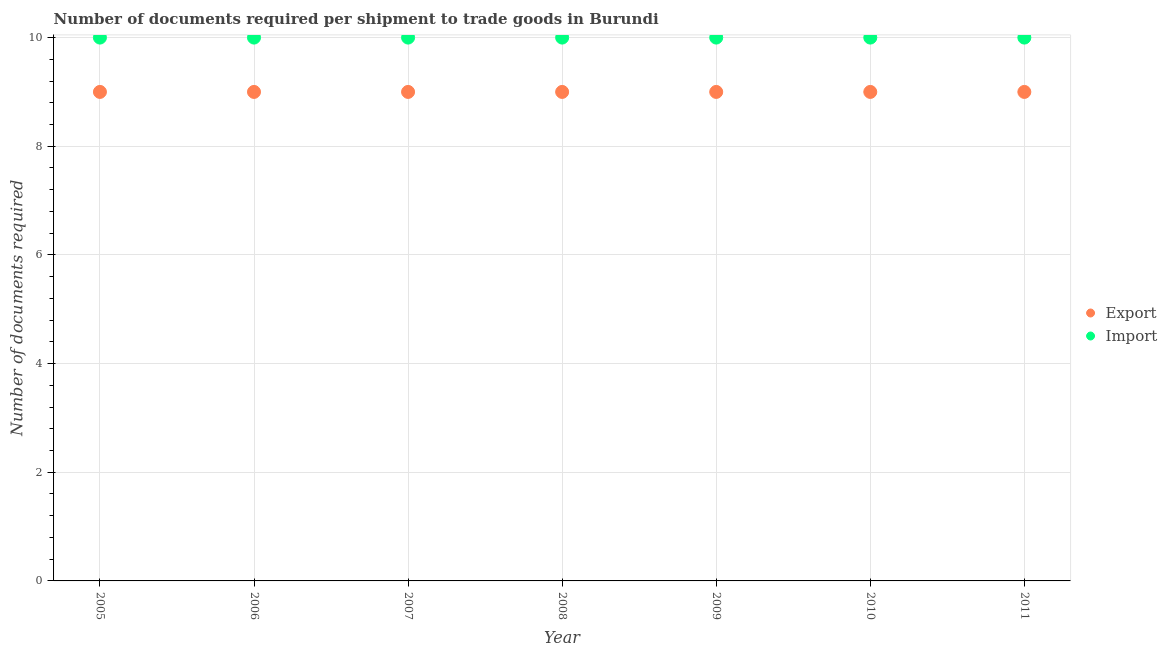How many different coloured dotlines are there?
Offer a terse response. 2. Is the number of dotlines equal to the number of legend labels?
Your response must be concise. Yes. What is the number of documents required to import goods in 2007?
Make the answer very short. 10. Across all years, what is the maximum number of documents required to export goods?
Provide a short and direct response. 9. Across all years, what is the minimum number of documents required to export goods?
Provide a succinct answer. 9. In which year was the number of documents required to export goods minimum?
Ensure brevity in your answer.  2005. What is the total number of documents required to import goods in the graph?
Provide a short and direct response. 70. What is the difference between the number of documents required to export goods in 2010 and the number of documents required to import goods in 2005?
Keep it short and to the point. -1. In the year 2010, what is the difference between the number of documents required to export goods and number of documents required to import goods?
Provide a succinct answer. -1. In how many years, is the number of documents required to import goods greater than 9.2?
Give a very brief answer. 7. What is the ratio of the number of documents required to export goods in 2005 to that in 2011?
Ensure brevity in your answer.  1. What is the difference between the highest and the lowest number of documents required to export goods?
Your answer should be very brief. 0. Is the sum of the number of documents required to import goods in 2006 and 2011 greater than the maximum number of documents required to export goods across all years?
Keep it short and to the point. Yes. Does the number of documents required to export goods monotonically increase over the years?
Offer a very short reply. No. Is the number of documents required to export goods strictly greater than the number of documents required to import goods over the years?
Ensure brevity in your answer.  No. How many years are there in the graph?
Provide a succinct answer. 7. Does the graph contain any zero values?
Your response must be concise. No. What is the title of the graph?
Your answer should be very brief. Number of documents required per shipment to trade goods in Burundi. What is the label or title of the Y-axis?
Offer a terse response. Number of documents required. What is the Number of documents required of Export in 2007?
Your response must be concise. 9. What is the Number of documents required in Import in 2007?
Provide a succinct answer. 10. What is the Number of documents required of Export in 2011?
Offer a terse response. 9. What is the Number of documents required in Import in 2011?
Give a very brief answer. 10. What is the difference between the Number of documents required of Import in 2005 and that in 2006?
Provide a succinct answer. 0. What is the difference between the Number of documents required in Export in 2005 and that in 2007?
Your response must be concise. 0. What is the difference between the Number of documents required in Import in 2005 and that in 2007?
Your answer should be compact. 0. What is the difference between the Number of documents required in Import in 2005 and that in 2009?
Provide a succinct answer. 0. What is the difference between the Number of documents required of Export in 2005 and that in 2010?
Offer a very short reply. 0. What is the difference between the Number of documents required in Export in 2005 and that in 2011?
Make the answer very short. 0. What is the difference between the Number of documents required in Import in 2005 and that in 2011?
Offer a very short reply. 0. What is the difference between the Number of documents required of Export in 2006 and that in 2008?
Make the answer very short. 0. What is the difference between the Number of documents required in Import in 2006 and that in 2009?
Give a very brief answer. 0. What is the difference between the Number of documents required of Export in 2006 and that in 2010?
Your answer should be compact. 0. What is the difference between the Number of documents required in Import in 2006 and that in 2010?
Offer a very short reply. 0. What is the difference between the Number of documents required of Export in 2006 and that in 2011?
Ensure brevity in your answer.  0. What is the difference between the Number of documents required of Export in 2007 and that in 2008?
Keep it short and to the point. 0. What is the difference between the Number of documents required in Import in 2007 and that in 2008?
Your answer should be compact. 0. What is the difference between the Number of documents required of Export in 2007 and that in 2009?
Offer a terse response. 0. What is the difference between the Number of documents required of Export in 2007 and that in 2011?
Your response must be concise. 0. What is the difference between the Number of documents required of Import in 2008 and that in 2009?
Offer a very short reply. 0. What is the difference between the Number of documents required of Export in 2008 and that in 2010?
Offer a terse response. 0. What is the difference between the Number of documents required in Export in 2009 and that in 2010?
Ensure brevity in your answer.  0. What is the difference between the Number of documents required of Import in 2009 and that in 2010?
Your answer should be compact. 0. What is the difference between the Number of documents required of Export in 2009 and that in 2011?
Ensure brevity in your answer.  0. What is the difference between the Number of documents required of Import in 2009 and that in 2011?
Ensure brevity in your answer.  0. What is the difference between the Number of documents required in Import in 2010 and that in 2011?
Ensure brevity in your answer.  0. What is the difference between the Number of documents required of Export in 2005 and the Number of documents required of Import in 2006?
Your answer should be compact. -1. What is the difference between the Number of documents required in Export in 2005 and the Number of documents required in Import in 2007?
Your response must be concise. -1. What is the difference between the Number of documents required in Export in 2005 and the Number of documents required in Import in 2008?
Provide a succinct answer. -1. What is the difference between the Number of documents required in Export in 2005 and the Number of documents required in Import in 2009?
Make the answer very short. -1. What is the difference between the Number of documents required in Export in 2005 and the Number of documents required in Import in 2010?
Provide a short and direct response. -1. What is the difference between the Number of documents required of Export in 2005 and the Number of documents required of Import in 2011?
Your answer should be very brief. -1. What is the difference between the Number of documents required in Export in 2006 and the Number of documents required in Import in 2008?
Provide a succinct answer. -1. What is the difference between the Number of documents required of Export in 2006 and the Number of documents required of Import in 2010?
Keep it short and to the point. -1. What is the difference between the Number of documents required in Export in 2006 and the Number of documents required in Import in 2011?
Offer a terse response. -1. What is the difference between the Number of documents required of Export in 2007 and the Number of documents required of Import in 2009?
Ensure brevity in your answer.  -1. What is the difference between the Number of documents required in Export in 2007 and the Number of documents required in Import in 2010?
Make the answer very short. -1. What is the difference between the Number of documents required in Export in 2007 and the Number of documents required in Import in 2011?
Your response must be concise. -1. What is the difference between the Number of documents required in Export in 2008 and the Number of documents required in Import in 2010?
Provide a short and direct response. -1. What is the difference between the Number of documents required of Export in 2008 and the Number of documents required of Import in 2011?
Your response must be concise. -1. What is the difference between the Number of documents required in Export in 2010 and the Number of documents required in Import in 2011?
Your response must be concise. -1. What is the average Number of documents required in Export per year?
Provide a succinct answer. 9. What is the average Number of documents required of Import per year?
Your answer should be very brief. 10. In the year 2005, what is the difference between the Number of documents required in Export and Number of documents required in Import?
Give a very brief answer. -1. In the year 2006, what is the difference between the Number of documents required of Export and Number of documents required of Import?
Provide a succinct answer. -1. In the year 2008, what is the difference between the Number of documents required in Export and Number of documents required in Import?
Your answer should be compact. -1. In the year 2011, what is the difference between the Number of documents required in Export and Number of documents required in Import?
Provide a short and direct response. -1. What is the ratio of the Number of documents required of Import in 2005 to that in 2007?
Give a very brief answer. 1. What is the ratio of the Number of documents required of Export in 2005 to that in 2009?
Your answer should be very brief. 1. What is the ratio of the Number of documents required in Import in 2005 to that in 2009?
Provide a short and direct response. 1. What is the ratio of the Number of documents required in Export in 2005 to that in 2011?
Provide a short and direct response. 1. What is the ratio of the Number of documents required in Import in 2005 to that in 2011?
Your response must be concise. 1. What is the ratio of the Number of documents required of Import in 2006 to that in 2007?
Your response must be concise. 1. What is the ratio of the Number of documents required in Import in 2006 to that in 2008?
Provide a succinct answer. 1. What is the ratio of the Number of documents required of Export in 2006 to that in 2009?
Provide a short and direct response. 1. What is the ratio of the Number of documents required of Export in 2006 to that in 2010?
Provide a succinct answer. 1. What is the ratio of the Number of documents required of Import in 2006 to that in 2010?
Your response must be concise. 1. What is the ratio of the Number of documents required in Export in 2007 to that in 2008?
Your response must be concise. 1. What is the ratio of the Number of documents required of Import in 2007 to that in 2008?
Your answer should be compact. 1. What is the ratio of the Number of documents required of Import in 2007 to that in 2011?
Offer a very short reply. 1. What is the ratio of the Number of documents required in Export in 2008 to that in 2009?
Make the answer very short. 1. What is the ratio of the Number of documents required of Export in 2008 to that in 2010?
Offer a very short reply. 1. What is the ratio of the Number of documents required of Import in 2008 to that in 2010?
Give a very brief answer. 1. What is the ratio of the Number of documents required in Import in 2008 to that in 2011?
Your answer should be compact. 1. What is the ratio of the Number of documents required in Import in 2009 to that in 2010?
Offer a terse response. 1. What is the ratio of the Number of documents required of Export in 2010 to that in 2011?
Give a very brief answer. 1. What is the difference between the highest and the second highest Number of documents required of Export?
Make the answer very short. 0. What is the difference between the highest and the second highest Number of documents required of Import?
Your answer should be very brief. 0. What is the difference between the highest and the lowest Number of documents required in Export?
Your answer should be compact. 0. What is the difference between the highest and the lowest Number of documents required in Import?
Your answer should be compact. 0. 